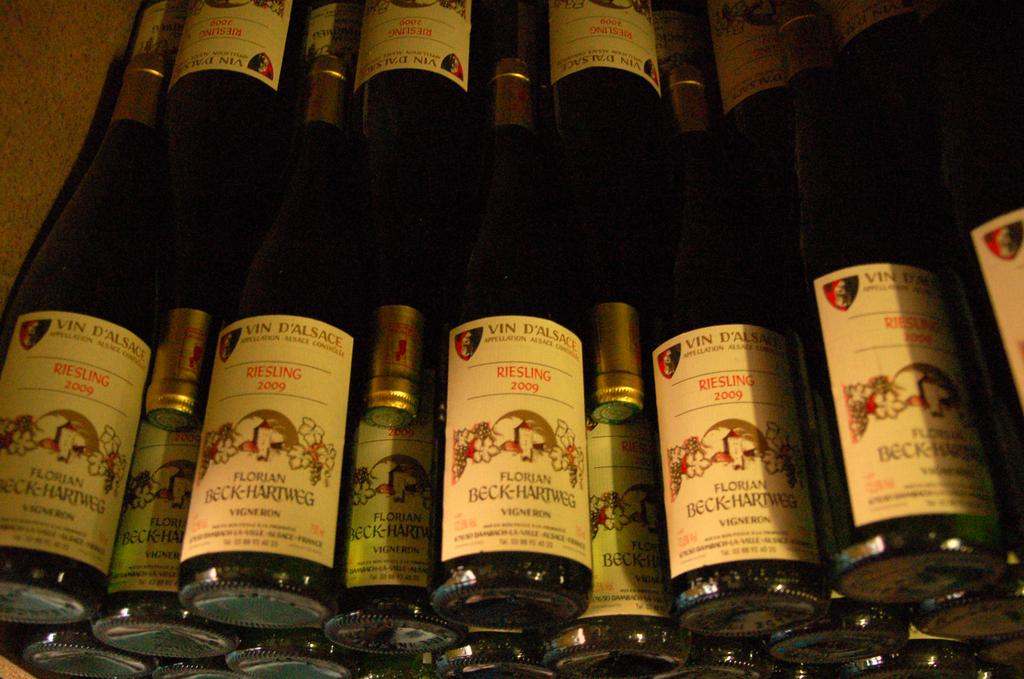What are those bottles?
Your answer should be compact. Riesling. What year were those bottled?
Your response must be concise. 2009. 